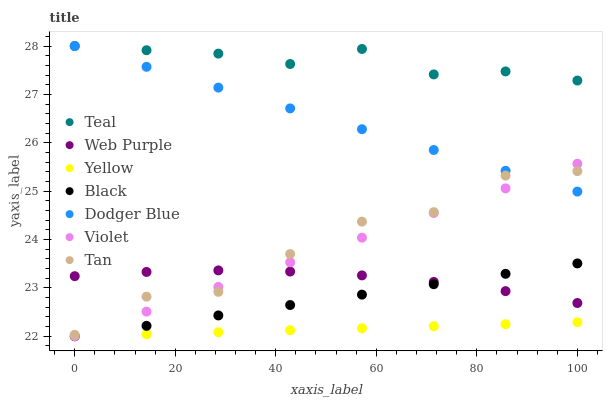Does Yellow have the minimum area under the curve?
Answer yes or no. Yes. Does Teal have the maximum area under the curve?
Answer yes or no. Yes. Does Web Purple have the minimum area under the curve?
Answer yes or no. No. Does Web Purple have the maximum area under the curve?
Answer yes or no. No. Is Yellow the smoothest?
Answer yes or no. Yes. Is Tan the roughest?
Answer yes or no. Yes. Is Web Purple the smoothest?
Answer yes or no. No. Is Web Purple the roughest?
Answer yes or no. No. Does Yellow have the lowest value?
Answer yes or no. Yes. Does Web Purple have the lowest value?
Answer yes or no. No. Does Teal have the highest value?
Answer yes or no. Yes. Does Web Purple have the highest value?
Answer yes or no. No. Is Black less than Dodger Blue?
Answer yes or no. Yes. Is Dodger Blue greater than Web Purple?
Answer yes or no. Yes. Does Black intersect Web Purple?
Answer yes or no. Yes. Is Black less than Web Purple?
Answer yes or no. No. Is Black greater than Web Purple?
Answer yes or no. No. Does Black intersect Dodger Blue?
Answer yes or no. No. 